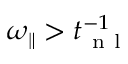Convert formula to latex. <formula><loc_0><loc_0><loc_500><loc_500>{ \omega _ { \| } } > t _ { n l } ^ { - 1 }</formula> 